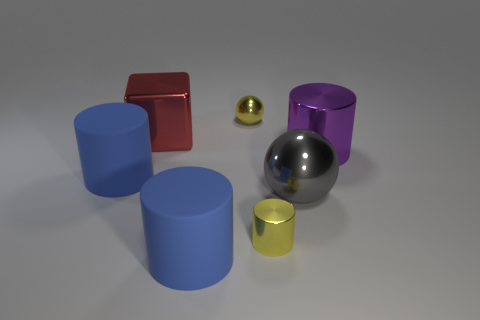How big is the blue object that is in front of the large rubber object to the left of the rubber thing that is in front of the gray ball?
Your answer should be very brief. Large. How many other things are made of the same material as the big red thing?
Provide a succinct answer. 4. There is a blue object that is on the left side of the cube; what is its size?
Offer a very short reply. Large. What number of large cylinders are left of the small cylinder and to the right of the red block?
Provide a short and direct response. 1. There is a small yellow object behind the small metal cylinder in front of the big block; what is it made of?
Your response must be concise. Metal. There is a small yellow thing that is the same shape as the purple metal thing; what is it made of?
Your response must be concise. Metal. Are any gray shiny balls visible?
Your answer should be compact. Yes. What is the shape of the tiny yellow thing that is made of the same material as the tiny yellow cylinder?
Your answer should be very brief. Sphere. What is the material of the small object in front of the small metal sphere?
Offer a terse response. Metal. Does the sphere that is in front of the big purple thing have the same color as the block?
Offer a terse response. No. 